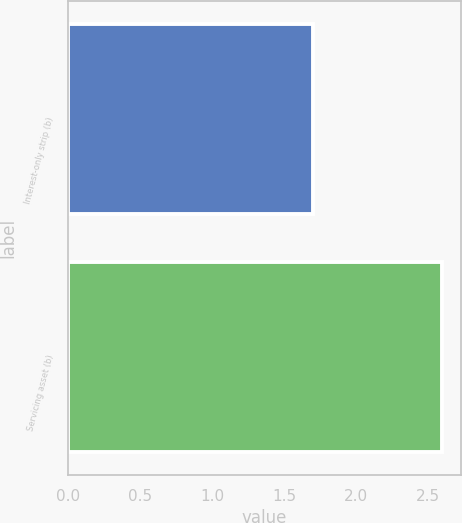Convert chart to OTSL. <chart><loc_0><loc_0><loc_500><loc_500><bar_chart><fcel>Interest-only strip (b)<fcel>Servicing asset (b)<nl><fcel>1.7<fcel>2.6<nl></chart> 